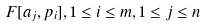<formula> <loc_0><loc_0><loc_500><loc_500>F [ a _ { j } , p _ { i } ] , 1 \leq i \leq m , 1 \leq j \leq n</formula> 